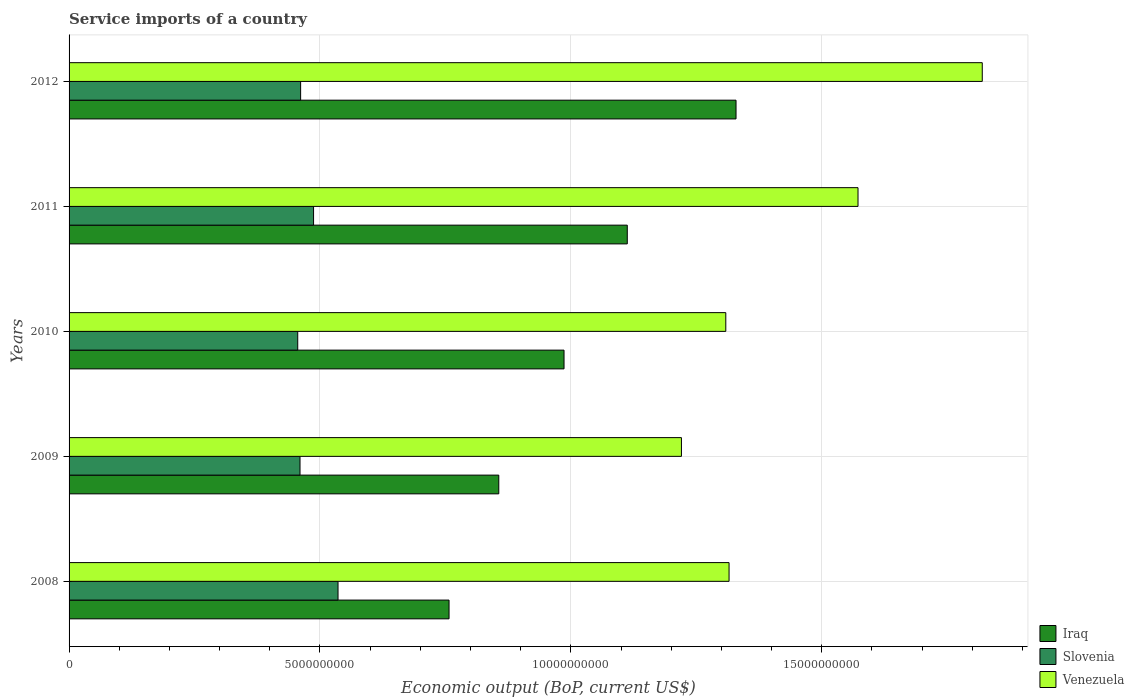How many different coloured bars are there?
Keep it short and to the point. 3. Are the number of bars per tick equal to the number of legend labels?
Ensure brevity in your answer.  Yes. How many bars are there on the 1st tick from the top?
Give a very brief answer. 3. How many bars are there on the 5th tick from the bottom?
Your response must be concise. 3. What is the label of the 5th group of bars from the top?
Provide a short and direct response. 2008. What is the service imports in Venezuela in 2009?
Offer a very short reply. 1.22e+1. Across all years, what is the maximum service imports in Slovenia?
Give a very brief answer. 5.36e+09. Across all years, what is the minimum service imports in Iraq?
Your response must be concise. 7.57e+09. What is the total service imports in Iraq in the graph?
Ensure brevity in your answer.  5.04e+1. What is the difference between the service imports in Iraq in 2008 and that in 2011?
Keep it short and to the point. -3.55e+09. What is the difference between the service imports in Venezuela in 2009 and the service imports in Iraq in 2012?
Ensure brevity in your answer.  -1.09e+09. What is the average service imports in Venezuela per year?
Your answer should be very brief. 1.45e+1. In the year 2010, what is the difference between the service imports in Iraq and service imports in Slovenia?
Provide a short and direct response. 5.31e+09. In how many years, is the service imports in Iraq greater than 12000000000 US$?
Ensure brevity in your answer.  1. What is the ratio of the service imports in Venezuela in 2010 to that in 2012?
Ensure brevity in your answer.  0.72. Is the service imports in Iraq in 2010 less than that in 2012?
Offer a terse response. Yes. What is the difference between the highest and the second highest service imports in Slovenia?
Keep it short and to the point. 4.88e+08. What is the difference between the highest and the lowest service imports in Slovenia?
Keep it short and to the point. 8.03e+08. In how many years, is the service imports in Slovenia greater than the average service imports in Slovenia taken over all years?
Your answer should be very brief. 2. Is the sum of the service imports in Venezuela in 2008 and 2010 greater than the maximum service imports in Iraq across all years?
Keep it short and to the point. Yes. What does the 1st bar from the top in 2010 represents?
Give a very brief answer. Venezuela. What does the 2nd bar from the bottom in 2008 represents?
Make the answer very short. Slovenia. How many bars are there?
Give a very brief answer. 15. Does the graph contain any zero values?
Give a very brief answer. No. Does the graph contain grids?
Your answer should be compact. Yes. How many legend labels are there?
Give a very brief answer. 3. What is the title of the graph?
Keep it short and to the point. Service imports of a country. Does "Kazakhstan" appear as one of the legend labels in the graph?
Give a very brief answer. No. What is the label or title of the X-axis?
Provide a short and direct response. Economic output (BoP, current US$). What is the label or title of the Y-axis?
Ensure brevity in your answer.  Years. What is the Economic output (BoP, current US$) of Iraq in 2008?
Your answer should be compact. 7.57e+09. What is the Economic output (BoP, current US$) in Slovenia in 2008?
Your answer should be very brief. 5.36e+09. What is the Economic output (BoP, current US$) in Venezuela in 2008?
Your answer should be very brief. 1.32e+1. What is the Economic output (BoP, current US$) of Iraq in 2009?
Your answer should be very brief. 8.56e+09. What is the Economic output (BoP, current US$) in Slovenia in 2009?
Offer a very short reply. 4.60e+09. What is the Economic output (BoP, current US$) in Venezuela in 2009?
Give a very brief answer. 1.22e+1. What is the Economic output (BoP, current US$) in Iraq in 2010?
Your response must be concise. 9.86e+09. What is the Economic output (BoP, current US$) of Slovenia in 2010?
Offer a very short reply. 4.56e+09. What is the Economic output (BoP, current US$) in Venezuela in 2010?
Your answer should be very brief. 1.31e+1. What is the Economic output (BoP, current US$) of Iraq in 2011?
Your answer should be compact. 1.11e+1. What is the Economic output (BoP, current US$) in Slovenia in 2011?
Keep it short and to the point. 4.87e+09. What is the Economic output (BoP, current US$) in Venezuela in 2011?
Keep it short and to the point. 1.57e+1. What is the Economic output (BoP, current US$) of Iraq in 2012?
Provide a short and direct response. 1.33e+1. What is the Economic output (BoP, current US$) in Slovenia in 2012?
Your response must be concise. 4.61e+09. What is the Economic output (BoP, current US$) of Venezuela in 2012?
Your response must be concise. 1.82e+1. Across all years, what is the maximum Economic output (BoP, current US$) in Iraq?
Your response must be concise. 1.33e+1. Across all years, what is the maximum Economic output (BoP, current US$) in Slovenia?
Give a very brief answer. 5.36e+09. Across all years, what is the maximum Economic output (BoP, current US$) in Venezuela?
Keep it short and to the point. 1.82e+1. Across all years, what is the minimum Economic output (BoP, current US$) of Iraq?
Provide a succinct answer. 7.57e+09. Across all years, what is the minimum Economic output (BoP, current US$) of Slovenia?
Your answer should be very brief. 4.56e+09. Across all years, what is the minimum Economic output (BoP, current US$) in Venezuela?
Provide a short and direct response. 1.22e+1. What is the total Economic output (BoP, current US$) of Iraq in the graph?
Offer a very short reply. 5.04e+1. What is the total Economic output (BoP, current US$) in Slovenia in the graph?
Offer a terse response. 2.40e+1. What is the total Economic output (BoP, current US$) in Venezuela in the graph?
Ensure brevity in your answer.  7.24e+1. What is the difference between the Economic output (BoP, current US$) in Iraq in 2008 and that in 2009?
Ensure brevity in your answer.  -9.91e+08. What is the difference between the Economic output (BoP, current US$) of Slovenia in 2008 and that in 2009?
Your answer should be very brief. 7.58e+08. What is the difference between the Economic output (BoP, current US$) in Venezuela in 2008 and that in 2009?
Provide a succinct answer. 9.49e+08. What is the difference between the Economic output (BoP, current US$) of Iraq in 2008 and that in 2010?
Your answer should be very brief. -2.29e+09. What is the difference between the Economic output (BoP, current US$) of Slovenia in 2008 and that in 2010?
Offer a terse response. 8.03e+08. What is the difference between the Economic output (BoP, current US$) of Venezuela in 2008 and that in 2010?
Your response must be concise. 6.50e+07. What is the difference between the Economic output (BoP, current US$) in Iraq in 2008 and that in 2011?
Provide a short and direct response. -3.55e+09. What is the difference between the Economic output (BoP, current US$) in Slovenia in 2008 and that in 2011?
Offer a terse response. 4.88e+08. What is the difference between the Economic output (BoP, current US$) of Venezuela in 2008 and that in 2011?
Offer a terse response. -2.57e+09. What is the difference between the Economic output (BoP, current US$) in Iraq in 2008 and that in 2012?
Offer a very short reply. -5.72e+09. What is the difference between the Economic output (BoP, current US$) in Slovenia in 2008 and that in 2012?
Make the answer very short. 7.45e+08. What is the difference between the Economic output (BoP, current US$) of Venezuela in 2008 and that in 2012?
Ensure brevity in your answer.  -5.05e+09. What is the difference between the Economic output (BoP, current US$) in Iraq in 2009 and that in 2010?
Ensure brevity in your answer.  -1.30e+09. What is the difference between the Economic output (BoP, current US$) in Slovenia in 2009 and that in 2010?
Your answer should be very brief. 4.56e+07. What is the difference between the Economic output (BoP, current US$) in Venezuela in 2009 and that in 2010?
Provide a short and direct response. -8.84e+08. What is the difference between the Economic output (BoP, current US$) in Iraq in 2009 and that in 2011?
Ensure brevity in your answer.  -2.56e+09. What is the difference between the Economic output (BoP, current US$) in Slovenia in 2009 and that in 2011?
Provide a short and direct response. -2.70e+08. What is the difference between the Economic output (BoP, current US$) of Venezuela in 2009 and that in 2011?
Offer a terse response. -3.52e+09. What is the difference between the Economic output (BoP, current US$) in Iraq in 2009 and that in 2012?
Your response must be concise. -4.73e+09. What is the difference between the Economic output (BoP, current US$) of Slovenia in 2009 and that in 2012?
Offer a terse response. -1.21e+07. What is the difference between the Economic output (BoP, current US$) in Venezuela in 2009 and that in 2012?
Provide a short and direct response. -6.00e+09. What is the difference between the Economic output (BoP, current US$) in Iraq in 2010 and that in 2011?
Keep it short and to the point. -1.26e+09. What is the difference between the Economic output (BoP, current US$) of Slovenia in 2010 and that in 2011?
Keep it short and to the point. -3.15e+08. What is the difference between the Economic output (BoP, current US$) of Venezuela in 2010 and that in 2011?
Offer a terse response. -2.64e+09. What is the difference between the Economic output (BoP, current US$) in Iraq in 2010 and that in 2012?
Provide a short and direct response. -3.43e+09. What is the difference between the Economic output (BoP, current US$) of Slovenia in 2010 and that in 2012?
Ensure brevity in your answer.  -5.78e+07. What is the difference between the Economic output (BoP, current US$) in Venezuela in 2010 and that in 2012?
Your response must be concise. -5.11e+09. What is the difference between the Economic output (BoP, current US$) of Iraq in 2011 and that in 2012?
Provide a succinct answer. -2.17e+09. What is the difference between the Economic output (BoP, current US$) of Slovenia in 2011 and that in 2012?
Give a very brief answer. 2.58e+08. What is the difference between the Economic output (BoP, current US$) in Venezuela in 2011 and that in 2012?
Make the answer very short. -2.48e+09. What is the difference between the Economic output (BoP, current US$) in Iraq in 2008 and the Economic output (BoP, current US$) in Slovenia in 2009?
Keep it short and to the point. 2.97e+09. What is the difference between the Economic output (BoP, current US$) of Iraq in 2008 and the Economic output (BoP, current US$) of Venezuela in 2009?
Your response must be concise. -4.63e+09. What is the difference between the Economic output (BoP, current US$) of Slovenia in 2008 and the Economic output (BoP, current US$) of Venezuela in 2009?
Your answer should be compact. -6.84e+09. What is the difference between the Economic output (BoP, current US$) of Iraq in 2008 and the Economic output (BoP, current US$) of Slovenia in 2010?
Give a very brief answer. 3.02e+09. What is the difference between the Economic output (BoP, current US$) of Iraq in 2008 and the Economic output (BoP, current US$) of Venezuela in 2010?
Provide a succinct answer. -5.52e+09. What is the difference between the Economic output (BoP, current US$) in Slovenia in 2008 and the Economic output (BoP, current US$) in Venezuela in 2010?
Offer a very short reply. -7.73e+09. What is the difference between the Economic output (BoP, current US$) in Iraq in 2008 and the Economic output (BoP, current US$) in Slovenia in 2011?
Offer a very short reply. 2.70e+09. What is the difference between the Economic output (BoP, current US$) of Iraq in 2008 and the Economic output (BoP, current US$) of Venezuela in 2011?
Keep it short and to the point. -8.15e+09. What is the difference between the Economic output (BoP, current US$) in Slovenia in 2008 and the Economic output (BoP, current US$) in Venezuela in 2011?
Offer a very short reply. -1.04e+1. What is the difference between the Economic output (BoP, current US$) in Iraq in 2008 and the Economic output (BoP, current US$) in Slovenia in 2012?
Provide a succinct answer. 2.96e+09. What is the difference between the Economic output (BoP, current US$) of Iraq in 2008 and the Economic output (BoP, current US$) of Venezuela in 2012?
Make the answer very short. -1.06e+1. What is the difference between the Economic output (BoP, current US$) in Slovenia in 2008 and the Economic output (BoP, current US$) in Venezuela in 2012?
Provide a succinct answer. -1.28e+1. What is the difference between the Economic output (BoP, current US$) of Iraq in 2009 and the Economic output (BoP, current US$) of Slovenia in 2010?
Keep it short and to the point. 4.01e+09. What is the difference between the Economic output (BoP, current US$) of Iraq in 2009 and the Economic output (BoP, current US$) of Venezuela in 2010?
Offer a very short reply. -4.52e+09. What is the difference between the Economic output (BoP, current US$) of Slovenia in 2009 and the Economic output (BoP, current US$) of Venezuela in 2010?
Ensure brevity in your answer.  -8.48e+09. What is the difference between the Economic output (BoP, current US$) in Iraq in 2009 and the Economic output (BoP, current US$) in Slovenia in 2011?
Keep it short and to the point. 3.69e+09. What is the difference between the Economic output (BoP, current US$) in Iraq in 2009 and the Economic output (BoP, current US$) in Venezuela in 2011?
Offer a terse response. -7.16e+09. What is the difference between the Economic output (BoP, current US$) of Slovenia in 2009 and the Economic output (BoP, current US$) of Venezuela in 2011?
Your response must be concise. -1.11e+1. What is the difference between the Economic output (BoP, current US$) in Iraq in 2009 and the Economic output (BoP, current US$) in Slovenia in 2012?
Offer a terse response. 3.95e+09. What is the difference between the Economic output (BoP, current US$) in Iraq in 2009 and the Economic output (BoP, current US$) in Venezuela in 2012?
Your answer should be compact. -9.63e+09. What is the difference between the Economic output (BoP, current US$) in Slovenia in 2009 and the Economic output (BoP, current US$) in Venezuela in 2012?
Provide a succinct answer. -1.36e+1. What is the difference between the Economic output (BoP, current US$) of Iraq in 2010 and the Economic output (BoP, current US$) of Slovenia in 2011?
Your answer should be very brief. 4.99e+09. What is the difference between the Economic output (BoP, current US$) of Iraq in 2010 and the Economic output (BoP, current US$) of Venezuela in 2011?
Offer a terse response. -5.86e+09. What is the difference between the Economic output (BoP, current US$) of Slovenia in 2010 and the Economic output (BoP, current US$) of Venezuela in 2011?
Offer a terse response. -1.12e+1. What is the difference between the Economic output (BoP, current US$) in Iraq in 2010 and the Economic output (BoP, current US$) in Slovenia in 2012?
Offer a terse response. 5.25e+09. What is the difference between the Economic output (BoP, current US$) of Iraq in 2010 and the Economic output (BoP, current US$) of Venezuela in 2012?
Your answer should be very brief. -8.33e+09. What is the difference between the Economic output (BoP, current US$) in Slovenia in 2010 and the Economic output (BoP, current US$) in Venezuela in 2012?
Provide a succinct answer. -1.36e+1. What is the difference between the Economic output (BoP, current US$) of Iraq in 2011 and the Economic output (BoP, current US$) of Slovenia in 2012?
Keep it short and to the point. 6.51e+09. What is the difference between the Economic output (BoP, current US$) in Iraq in 2011 and the Economic output (BoP, current US$) in Venezuela in 2012?
Your answer should be very brief. -7.07e+09. What is the difference between the Economic output (BoP, current US$) of Slovenia in 2011 and the Economic output (BoP, current US$) of Venezuela in 2012?
Ensure brevity in your answer.  -1.33e+1. What is the average Economic output (BoP, current US$) of Iraq per year?
Provide a short and direct response. 1.01e+1. What is the average Economic output (BoP, current US$) of Slovenia per year?
Give a very brief answer. 4.80e+09. What is the average Economic output (BoP, current US$) of Venezuela per year?
Offer a very short reply. 1.45e+1. In the year 2008, what is the difference between the Economic output (BoP, current US$) of Iraq and Economic output (BoP, current US$) of Slovenia?
Offer a terse response. 2.21e+09. In the year 2008, what is the difference between the Economic output (BoP, current US$) in Iraq and Economic output (BoP, current US$) in Venezuela?
Offer a terse response. -5.58e+09. In the year 2008, what is the difference between the Economic output (BoP, current US$) in Slovenia and Economic output (BoP, current US$) in Venezuela?
Your response must be concise. -7.79e+09. In the year 2009, what is the difference between the Economic output (BoP, current US$) of Iraq and Economic output (BoP, current US$) of Slovenia?
Ensure brevity in your answer.  3.96e+09. In the year 2009, what is the difference between the Economic output (BoP, current US$) of Iraq and Economic output (BoP, current US$) of Venezuela?
Keep it short and to the point. -3.64e+09. In the year 2009, what is the difference between the Economic output (BoP, current US$) in Slovenia and Economic output (BoP, current US$) in Venezuela?
Make the answer very short. -7.60e+09. In the year 2010, what is the difference between the Economic output (BoP, current US$) in Iraq and Economic output (BoP, current US$) in Slovenia?
Provide a short and direct response. 5.31e+09. In the year 2010, what is the difference between the Economic output (BoP, current US$) of Iraq and Economic output (BoP, current US$) of Venezuela?
Provide a short and direct response. -3.22e+09. In the year 2010, what is the difference between the Economic output (BoP, current US$) in Slovenia and Economic output (BoP, current US$) in Venezuela?
Provide a succinct answer. -8.53e+09. In the year 2011, what is the difference between the Economic output (BoP, current US$) of Iraq and Economic output (BoP, current US$) of Slovenia?
Provide a succinct answer. 6.25e+09. In the year 2011, what is the difference between the Economic output (BoP, current US$) in Iraq and Economic output (BoP, current US$) in Venezuela?
Your response must be concise. -4.60e+09. In the year 2011, what is the difference between the Economic output (BoP, current US$) in Slovenia and Economic output (BoP, current US$) in Venezuela?
Offer a terse response. -1.08e+1. In the year 2012, what is the difference between the Economic output (BoP, current US$) in Iraq and Economic output (BoP, current US$) in Slovenia?
Your response must be concise. 8.68e+09. In the year 2012, what is the difference between the Economic output (BoP, current US$) of Iraq and Economic output (BoP, current US$) of Venezuela?
Your answer should be very brief. -4.91e+09. In the year 2012, what is the difference between the Economic output (BoP, current US$) of Slovenia and Economic output (BoP, current US$) of Venezuela?
Offer a very short reply. -1.36e+1. What is the ratio of the Economic output (BoP, current US$) in Iraq in 2008 to that in 2009?
Provide a short and direct response. 0.88. What is the ratio of the Economic output (BoP, current US$) in Slovenia in 2008 to that in 2009?
Make the answer very short. 1.16. What is the ratio of the Economic output (BoP, current US$) in Venezuela in 2008 to that in 2009?
Give a very brief answer. 1.08. What is the ratio of the Economic output (BoP, current US$) of Iraq in 2008 to that in 2010?
Ensure brevity in your answer.  0.77. What is the ratio of the Economic output (BoP, current US$) in Slovenia in 2008 to that in 2010?
Your answer should be very brief. 1.18. What is the ratio of the Economic output (BoP, current US$) in Venezuela in 2008 to that in 2010?
Keep it short and to the point. 1. What is the ratio of the Economic output (BoP, current US$) of Iraq in 2008 to that in 2011?
Keep it short and to the point. 0.68. What is the ratio of the Economic output (BoP, current US$) in Slovenia in 2008 to that in 2011?
Keep it short and to the point. 1.1. What is the ratio of the Economic output (BoP, current US$) of Venezuela in 2008 to that in 2011?
Make the answer very short. 0.84. What is the ratio of the Economic output (BoP, current US$) in Iraq in 2008 to that in 2012?
Offer a very short reply. 0.57. What is the ratio of the Economic output (BoP, current US$) of Slovenia in 2008 to that in 2012?
Offer a terse response. 1.16. What is the ratio of the Economic output (BoP, current US$) of Venezuela in 2008 to that in 2012?
Your answer should be compact. 0.72. What is the ratio of the Economic output (BoP, current US$) of Iraq in 2009 to that in 2010?
Your answer should be very brief. 0.87. What is the ratio of the Economic output (BoP, current US$) in Venezuela in 2009 to that in 2010?
Make the answer very short. 0.93. What is the ratio of the Economic output (BoP, current US$) of Iraq in 2009 to that in 2011?
Keep it short and to the point. 0.77. What is the ratio of the Economic output (BoP, current US$) in Slovenia in 2009 to that in 2011?
Offer a terse response. 0.94. What is the ratio of the Economic output (BoP, current US$) in Venezuela in 2009 to that in 2011?
Your response must be concise. 0.78. What is the ratio of the Economic output (BoP, current US$) of Iraq in 2009 to that in 2012?
Offer a terse response. 0.64. What is the ratio of the Economic output (BoP, current US$) in Slovenia in 2009 to that in 2012?
Your answer should be compact. 1. What is the ratio of the Economic output (BoP, current US$) in Venezuela in 2009 to that in 2012?
Your response must be concise. 0.67. What is the ratio of the Economic output (BoP, current US$) of Iraq in 2010 to that in 2011?
Your answer should be very brief. 0.89. What is the ratio of the Economic output (BoP, current US$) of Slovenia in 2010 to that in 2011?
Provide a short and direct response. 0.94. What is the ratio of the Economic output (BoP, current US$) of Venezuela in 2010 to that in 2011?
Keep it short and to the point. 0.83. What is the ratio of the Economic output (BoP, current US$) of Iraq in 2010 to that in 2012?
Provide a short and direct response. 0.74. What is the ratio of the Economic output (BoP, current US$) of Slovenia in 2010 to that in 2012?
Provide a succinct answer. 0.99. What is the ratio of the Economic output (BoP, current US$) in Venezuela in 2010 to that in 2012?
Provide a succinct answer. 0.72. What is the ratio of the Economic output (BoP, current US$) in Iraq in 2011 to that in 2012?
Offer a very short reply. 0.84. What is the ratio of the Economic output (BoP, current US$) of Slovenia in 2011 to that in 2012?
Offer a terse response. 1.06. What is the ratio of the Economic output (BoP, current US$) in Venezuela in 2011 to that in 2012?
Make the answer very short. 0.86. What is the difference between the highest and the second highest Economic output (BoP, current US$) of Iraq?
Provide a short and direct response. 2.17e+09. What is the difference between the highest and the second highest Economic output (BoP, current US$) of Slovenia?
Your answer should be compact. 4.88e+08. What is the difference between the highest and the second highest Economic output (BoP, current US$) of Venezuela?
Your answer should be compact. 2.48e+09. What is the difference between the highest and the lowest Economic output (BoP, current US$) of Iraq?
Ensure brevity in your answer.  5.72e+09. What is the difference between the highest and the lowest Economic output (BoP, current US$) of Slovenia?
Offer a very short reply. 8.03e+08. What is the difference between the highest and the lowest Economic output (BoP, current US$) of Venezuela?
Keep it short and to the point. 6.00e+09. 